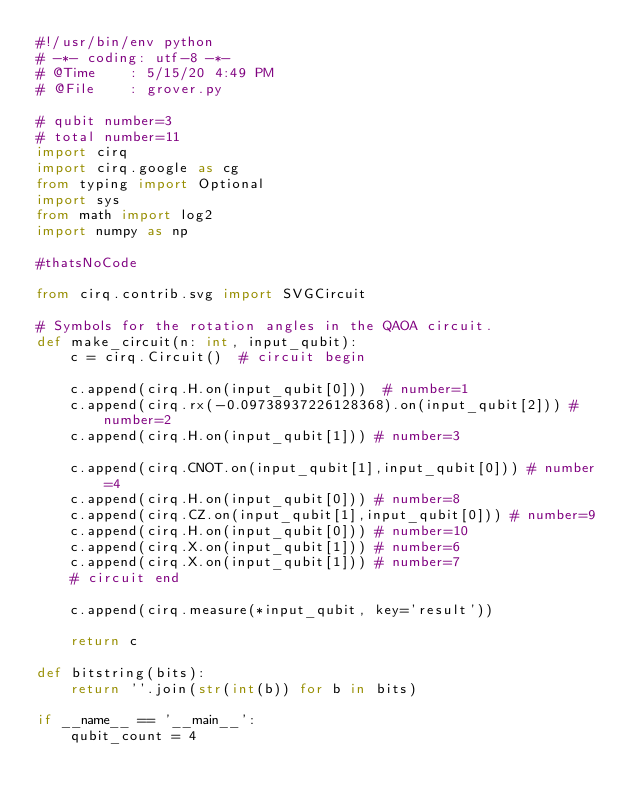Convert code to text. <code><loc_0><loc_0><loc_500><loc_500><_Python_>#!/usr/bin/env python
# -*- coding: utf-8 -*-
# @Time    : 5/15/20 4:49 PM
# @File    : grover.py

# qubit number=3
# total number=11
import cirq
import cirq.google as cg
from typing import Optional
import sys
from math import log2
import numpy as np

#thatsNoCode

from cirq.contrib.svg import SVGCircuit

# Symbols for the rotation angles in the QAOA circuit.
def make_circuit(n: int, input_qubit):
    c = cirq.Circuit()  # circuit begin

    c.append(cirq.H.on(input_qubit[0]))  # number=1
    c.append(cirq.rx(-0.09738937226128368).on(input_qubit[2])) # number=2
    c.append(cirq.H.on(input_qubit[1])) # number=3

    c.append(cirq.CNOT.on(input_qubit[1],input_qubit[0])) # number=4
    c.append(cirq.H.on(input_qubit[0])) # number=8
    c.append(cirq.CZ.on(input_qubit[1],input_qubit[0])) # number=9
    c.append(cirq.H.on(input_qubit[0])) # number=10
    c.append(cirq.X.on(input_qubit[1])) # number=6
    c.append(cirq.X.on(input_qubit[1])) # number=7
    # circuit end

    c.append(cirq.measure(*input_qubit, key='result'))

    return c

def bitstring(bits):
    return ''.join(str(int(b)) for b in bits)

if __name__ == '__main__':
    qubit_count = 4
</code> 